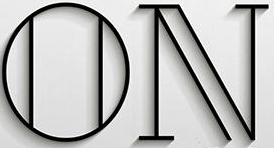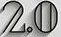What text is displayed in these images sequentially, separated by a semicolon? ON; 2.0 